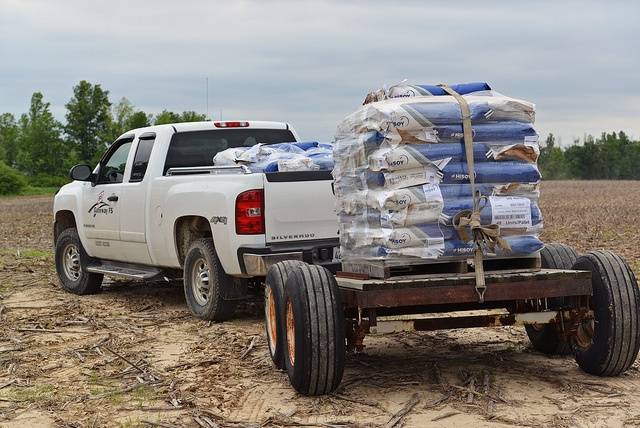Describe the objects in this image and their specific colors. I can see a truck in lightgray, black, darkgray, and gray tones in this image. 